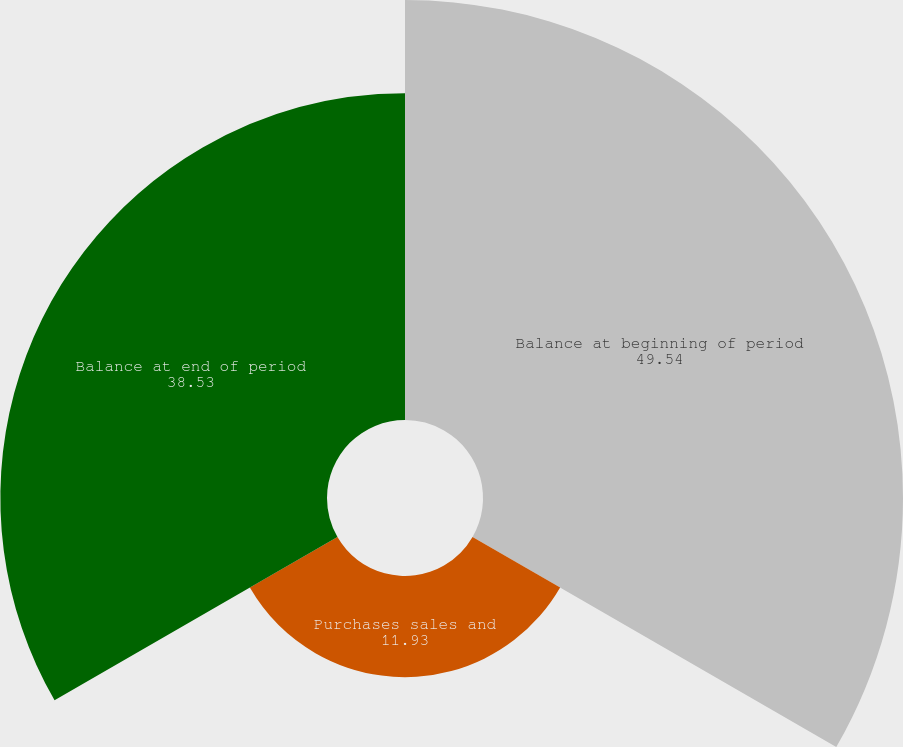<chart> <loc_0><loc_0><loc_500><loc_500><pie_chart><fcel>Balance at beginning of period<fcel>Purchases sales and<fcel>Balance at end of period<nl><fcel>49.54%<fcel>11.93%<fcel>38.53%<nl></chart> 